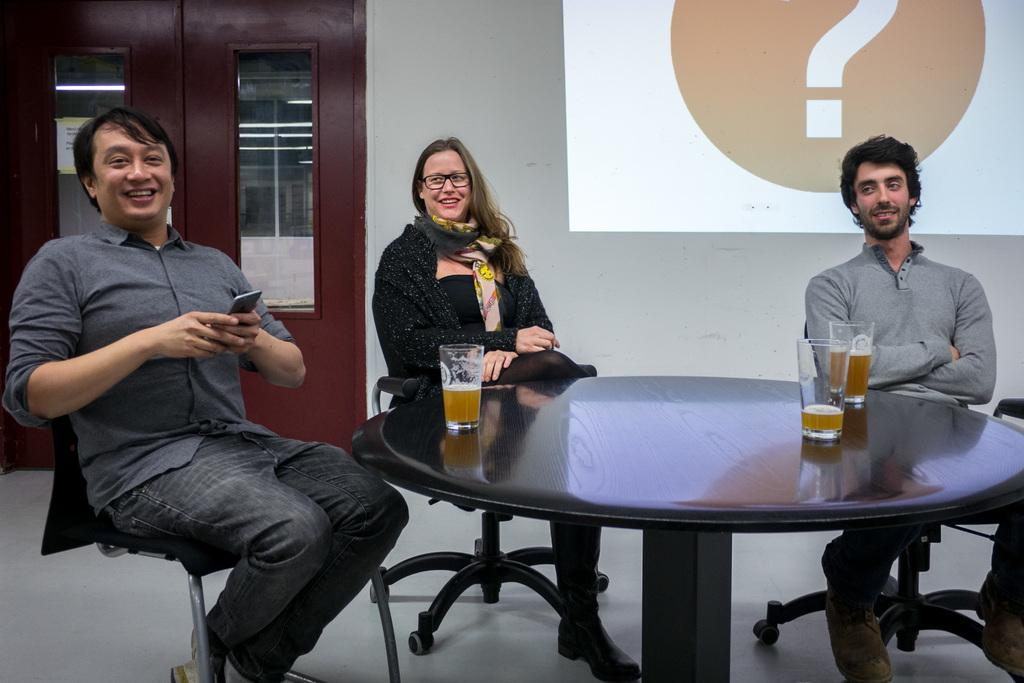What type of structure can be seen in the image? There is a door and a wall in the image. What is present on the wall in the image? There is a screen on the wall in the image. How many people are sitting in the image? There are three people sitting on chairs in the image. What furniture is visible in the image? There is a table in the image. What objects can be seen on the table? There are glasses on the table in the image. Is there any snow visible in the image? No, there is no snow present in the image. Are the three people in the image engaged in a fight? No, the three people in the image are sitting calmly on chairs and do not appear to be fighting. 